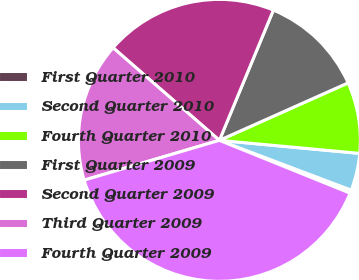<chart> <loc_0><loc_0><loc_500><loc_500><pie_chart><fcel>First Quarter 2010<fcel>Second Quarter 2010<fcel>Fourth Quarter 2010<fcel>First Quarter 2009<fcel>Second Quarter 2009<fcel>Third Quarter 2009<fcel>Fourth Quarter 2009<nl><fcel>0.37%<fcel>4.27%<fcel>8.16%<fcel>12.06%<fcel>19.85%<fcel>15.96%<fcel>39.33%<nl></chart> 